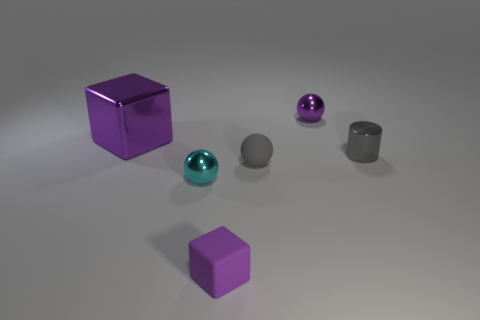Do the purple shiny thing that is behind the big metallic object and the tiny purple matte thing have the same shape?
Keep it short and to the point. No. Are there fewer tiny cyan metallic objects than cubes?
Offer a terse response. Yes. Is there any other thing that is the same color as the tiny rubber ball?
Give a very brief answer. Yes. What is the shape of the purple object in front of the big metallic thing?
Your answer should be compact. Cube. There is a rubber block; does it have the same color as the thing on the right side of the small purple shiny thing?
Ensure brevity in your answer.  No. Is the number of small metallic objects on the right side of the cyan object the same as the number of cylinders behind the tiny purple metallic thing?
Offer a terse response. No. What number of other objects are the same size as the purple rubber thing?
Give a very brief answer. 4. The purple matte object has what size?
Offer a terse response. Small. Does the big purple thing have the same material as the cube that is in front of the cylinder?
Provide a succinct answer. No. Are there any cyan things of the same shape as the tiny gray shiny object?
Offer a very short reply. No. 